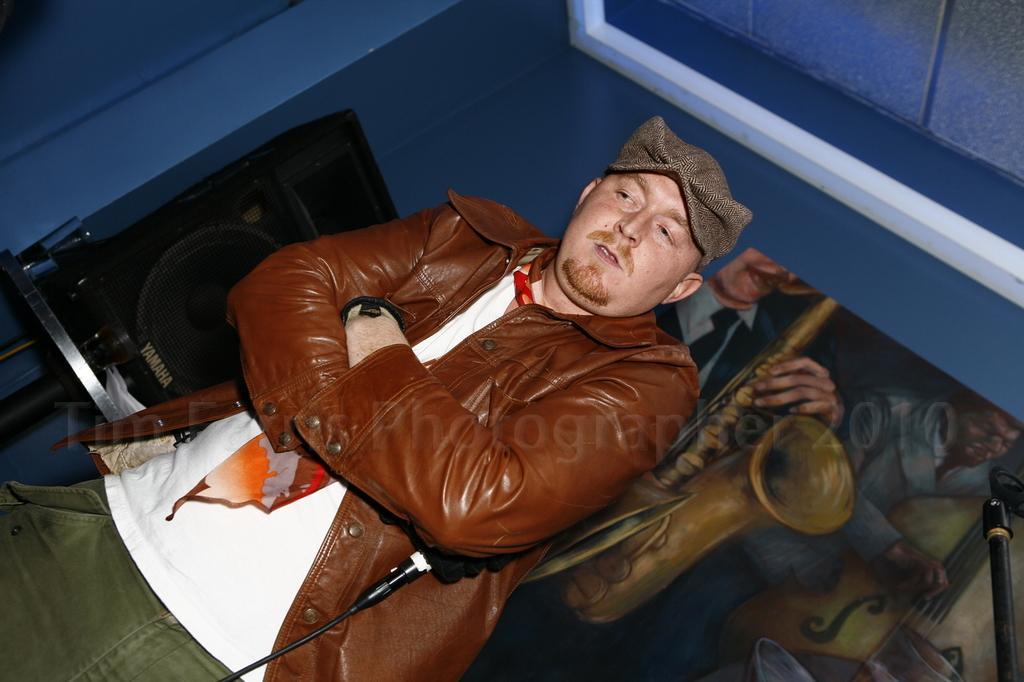Please provide a concise description of this image. Here in this picture we can see a person standing on the floor and we can see a brown colored jacket on him and he is holding a microphone in his hand and we can see he is wearing gloves and cap on him and behind him we can see a speaker present on the table over there and we can also see a painting present on the wall over there. 